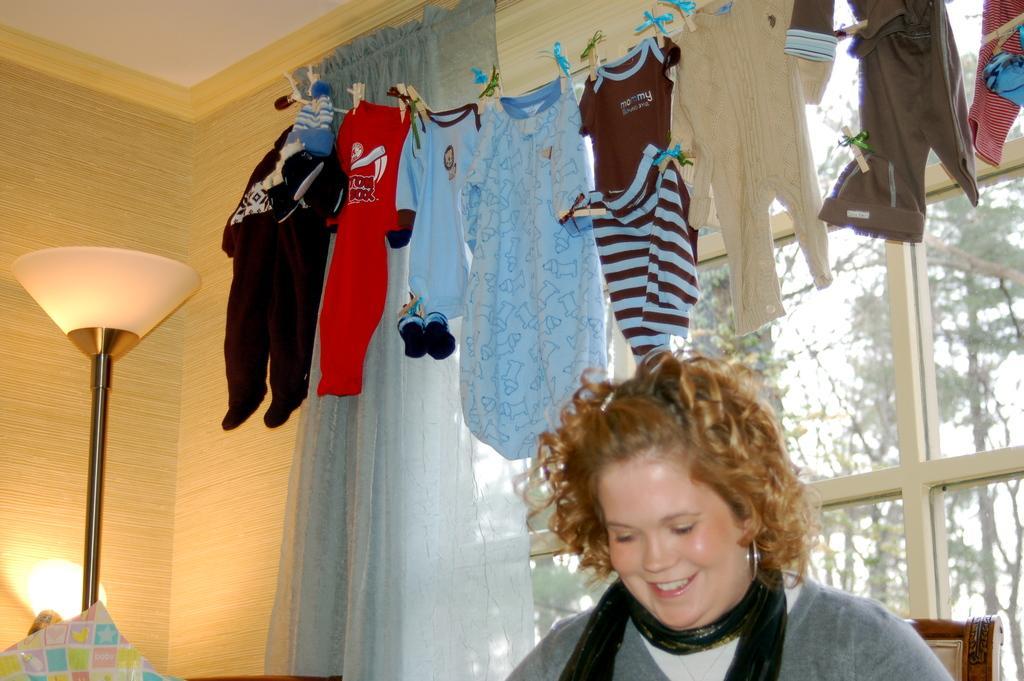Describe this image in one or two sentences. Here clothes are hanging, this is a woman, this is lamp, there are trees, this is curtain. 